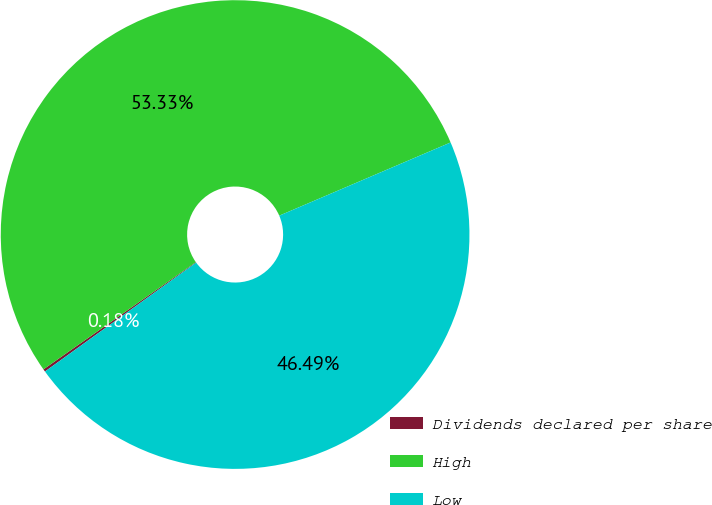Convert chart to OTSL. <chart><loc_0><loc_0><loc_500><loc_500><pie_chart><fcel>Dividends declared per share<fcel>High<fcel>Low<nl><fcel>0.18%<fcel>53.33%<fcel>46.49%<nl></chart> 